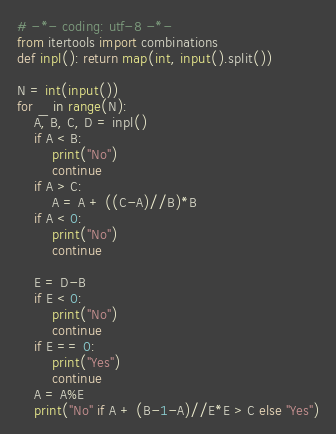<code> <loc_0><loc_0><loc_500><loc_500><_Python_># -*- coding: utf-8 -*-
from itertools import combinations
def inpl(): return map(int, input().split())

N = int(input())
for _ in range(N):
    A, B, C, D = inpl()
    if A < B:
        print("No")
        continue
    if A > C:
        A = A + ((C-A)//B)*B
    if A < 0:
        print("No")
        continue

    E = D-B
    if E < 0:
        print("No")
        continue
    if E == 0:
        print("Yes")
        continue
    A = A%E
    print("No" if A + (B-1-A)//E*E > C else "Yes")</code> 